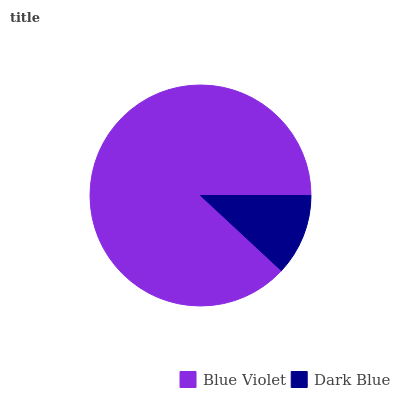Is Dark Blue the minimum?
Answer yes or no. Yes. Is Blue Violet the maximum?
Answer yes or no. Yes. Is Dark Blue the maximum?
Answer yes or no. No. Is Blue Violet greater than Dark Blue?
Answer yes or no. Yes. Is Dark Blue less than Blue Violet?
Answer yes or no. Yes. Is Dark Blue greater than Blue Violet?
Answer yes or no. No. Is Blue Violet less than Dark Blue?
Answer yes or no. No. Is Blue Violet the high median?
Answer yes or no. Yes. Is Dark Blue the low median?
Answer yes or no. Yes. Is Dark Blue the high median?
Answer yes or no. No. Is Blue Violet the low median?
Answer yes or no. No. 